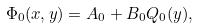<formula> <loc_0><loc_0><loc_500><loc_500>\Phi _ { 0 } ( x , y ) = A _ { 0 } + B _ { 0 } Q _ { 0 } ( y ) ,</formula> 